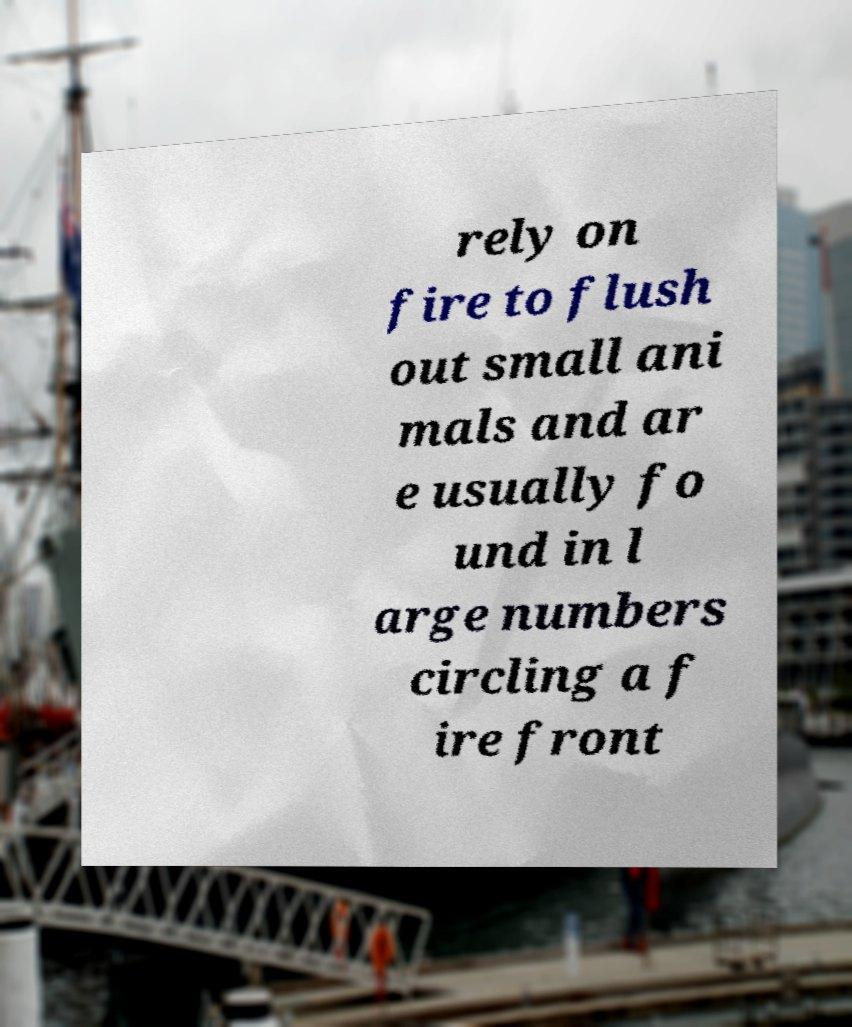Could you extract and type out the text from this image? rely on fire to flush out small ani mals and ar e usually fo und in l arge numbers circling a f ire front 